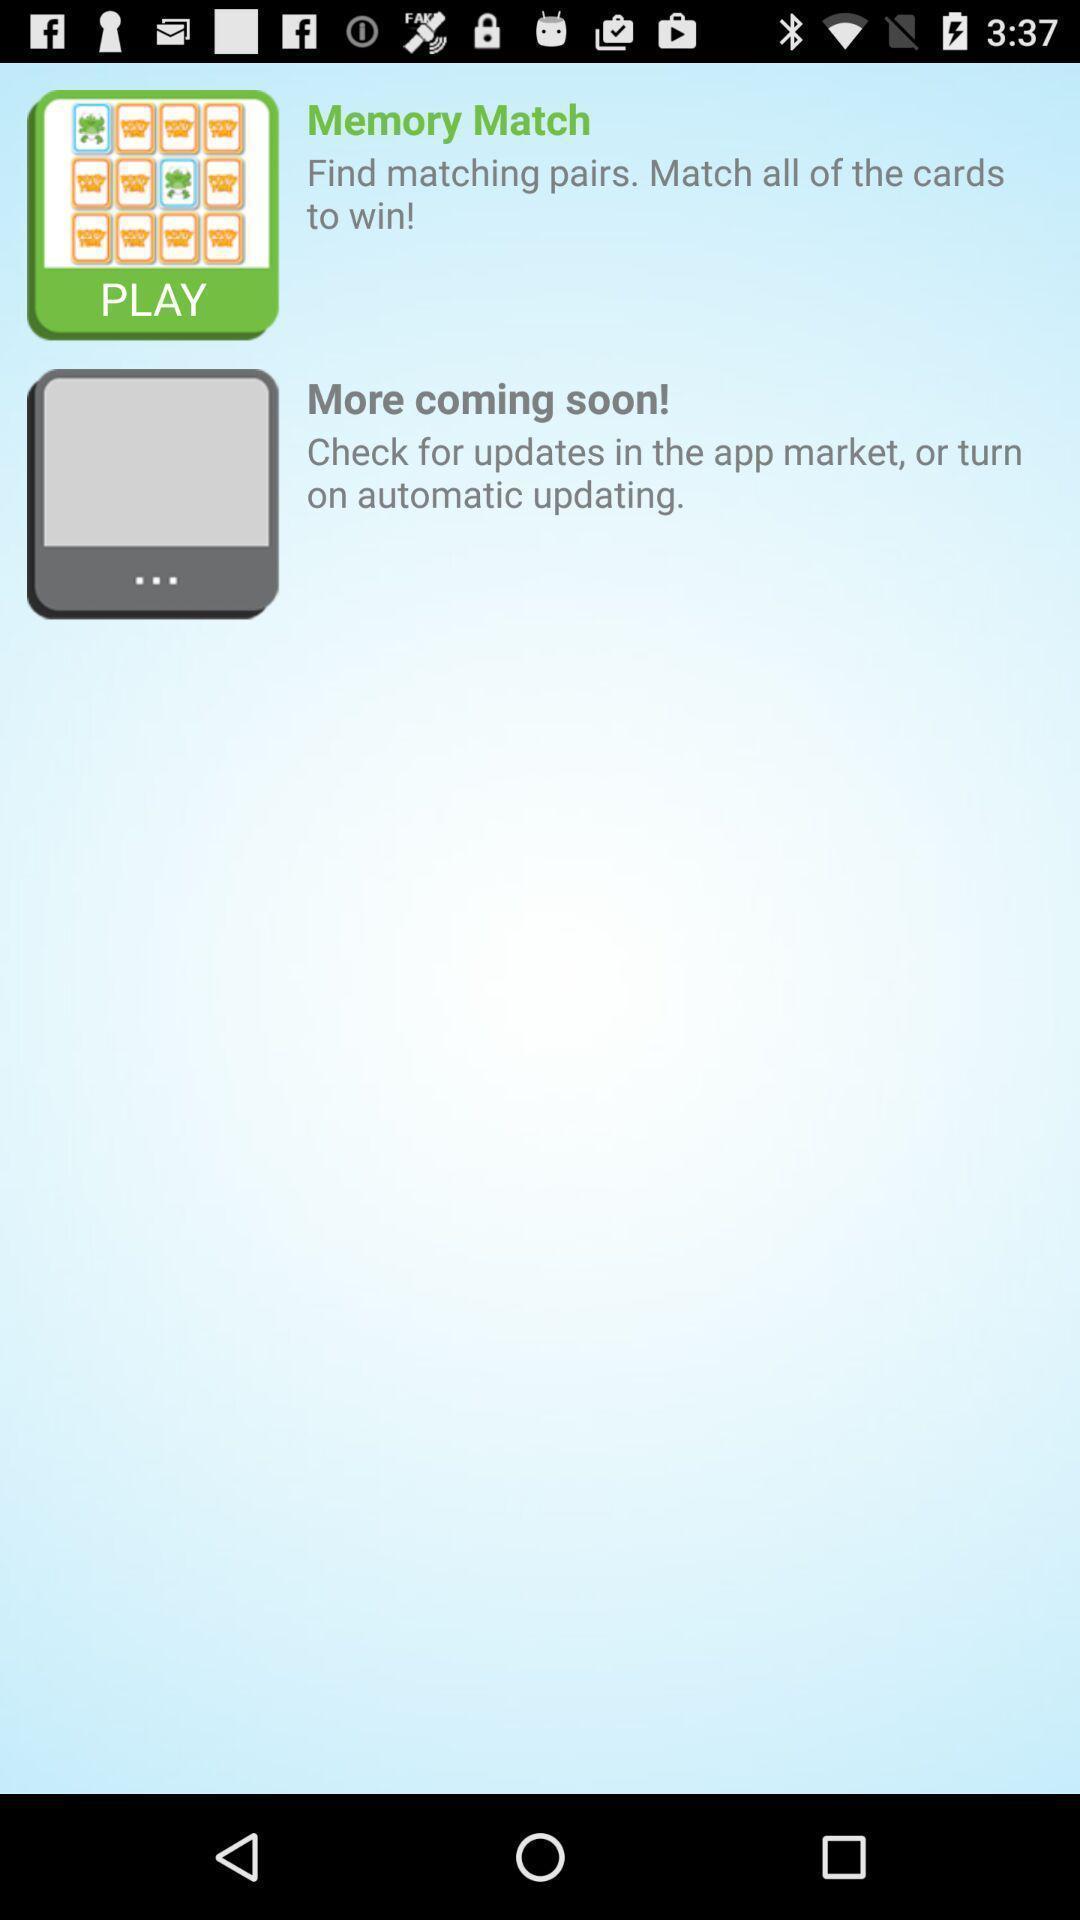Summarize the information in this screenshot. Screen displaying the list of games. 